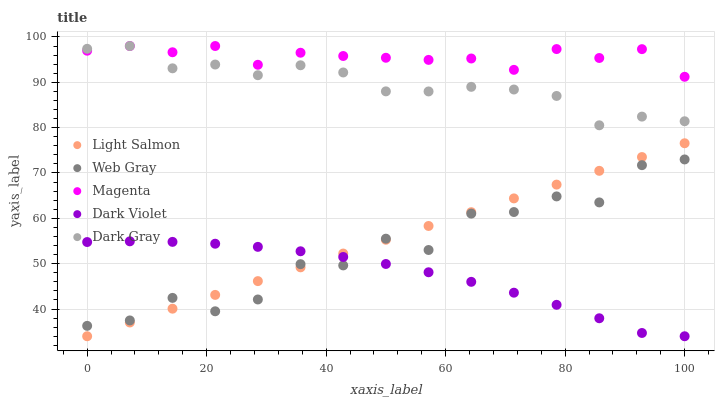Does Dark Violet have the minimum area under the curve?
Answer yes or no. Yes. Does Magenta have the maximum area under the curve?
Answer yes or no. Yes. Does Light Salmon have the minimum area under the curve?
Answer yes or no. No. Does Light Salmon have the maximum area under the curve?
Answer yes or no. No. Is Light Salmon the smoothest?
Answer yes or no. Yes. Is Web Gray the roughest?
Answer yes or no. Yes. Is Web Gray the smoothest?
Answer yes or no. No. Is Light Salmon the roughest?
Answer yes or no. No. Does Light Salmon have the lowest value?
Answer yes or no. Yes. Does Web Gray have the lowest value?
Answer yes or no. No. Does Magenta have the highest value?
Answer yes or no. Yes. Does Light Salmon have the highest value?
Answer yes or no. No. Is Web Gray less than Dark Gray?
Answer yes or no. Yes. Is Dark Gray greater than Dark Violet?
Answer yes or no. Yes. Does Light Salmon intersect Web Gray?
Answer yes or no. Yes. Is Light Salmon less than Web Gray?
Answer yes or no. No. Is Light Salmon greater than Web Gray?
Answer yes or no. No. Does Web Gray intersect Dark Gray?
Answer yes or no. No. 